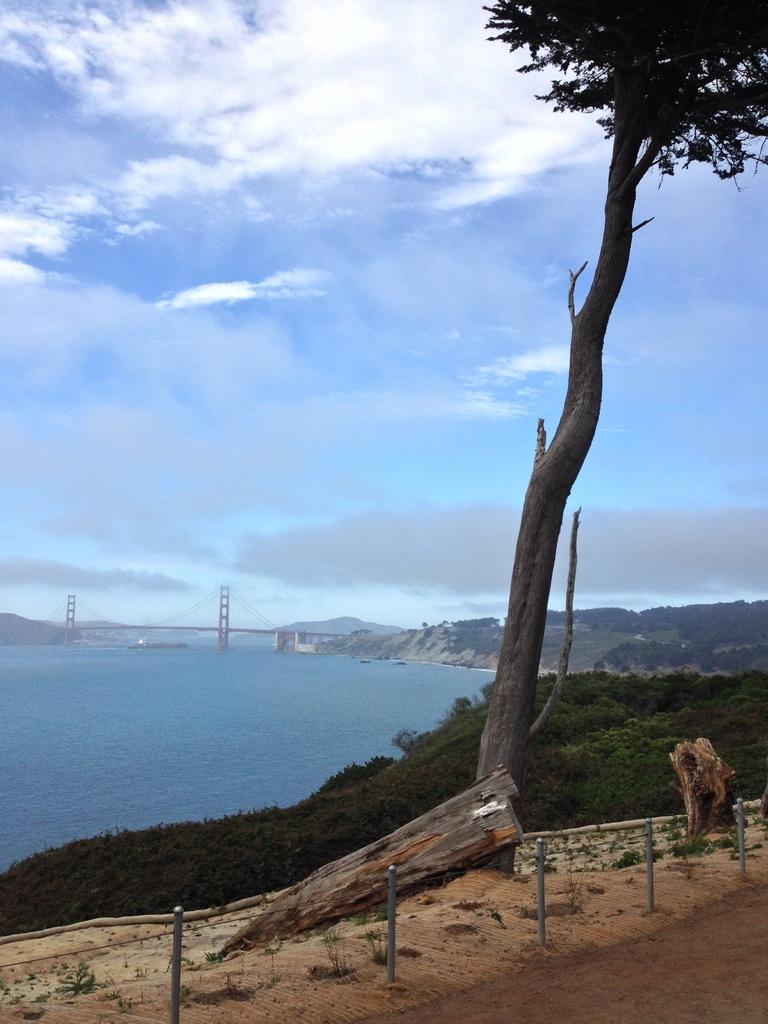What type of terrain is visible in the image? Ground is visible in the image. What type of vegetation can be seen in the image? There is a tree in the image, and its trunk is visible. What body of water is present in the image? There is water in the image. What type of structure is present in the image? There is a bridge in the image. What type of man-made objects are present in the image? There are poles in the image. What type of natural formation is visible in the image? There are mountains in the image. What part of the sky is visible in the image? The sky is visible in the image. What type of weather can be inferred from the image? Clouds are present in the sky, suggesting a partly cloudy day. How many trucks are parked near the mountains in the image? There are no trucks present in the image. Is there a notebook visible on the bridge in the image? There is no notebook present in the image. 